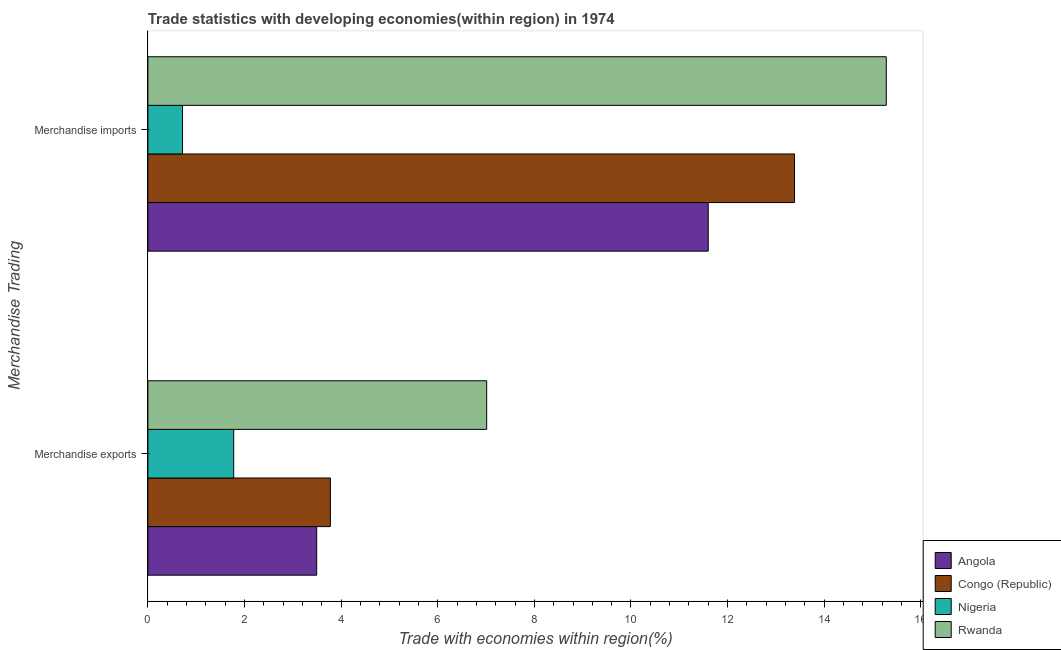How many different coloured bars are there?
Your answer should be compact. 4. How many bars are there on the 2nd tick from the bottom?
Offer a terse response. 4. What is the merchandise exports in Rwanda?
Your answer should be very brief. 7.01. Across all countries, what is the maximum merchandise exports?
Ensure brevity in your answer.  7.01. Across all countries, what is the minimum merchandise exports?
Your response must be concise. 1.78. In which country was the merchandise imports maximum?
Offer a terse response. Rwanda. In which country was the merchandise imports minimum?
Make the answer very short. Nigeria. What is the total merchandise exports in the graph?
Your answer should be compact. 16.06. What is the difference between the merchandise exports in Congo (Republic) and that in Angola?
Provide a succinct answer. 0.28. What is the difference between the merchandise exports in Congo (Republic) and the merchandise imports in Angola?
Keep it short and to the point. -7.82. What is the average merchandise exports per country?
Provide a succinct answer. 4.02. What is the difference between the merchandise exports and merchandise imports in Nigeria?
Your answer should be very brief. 1.06. What is the ratio of the merchandise imports in Angola to that in Congo (Republic)?
Your answer should be compact. 0.87. Is the merchandise exports in Nigeria less than that in Congo (Republic)?
Your answer should be compact. Yes. What does the 3rd bar from the top in Merchandise exports represents?
Provide a succinct answer. Congo (Republic). What does the 4th bar from the bottom in Merchandise imports represents?
Offer a very short reply. Rwanda. How many bars are there?
Ensure brevity in your answer.  8. What is the difference between two consecutive major ticks on the X-axis?
Provide a short and direct response. 2. Does the graph contain any zero values?
Offer a terse response. No. Does the graph contain grids?
Provide a succinct answer. No. Where does the legend appear in the graph?
Ensure brevity in your answer.  Bottom right. How many legend labels are there?
Offer a terse response. 4. How are the legend labels stacked?
Provide a succinct answer. Vertical. What is the title of the graph?
Provide a succinct answer. Trade statistics with developing economies(within region) in 1974. Does "Arab World" appear as one of the legend labels in the graph?
Keep it short and to the point. No. What is the label or title of the X-axis?
Your answer should be compact. Trade with economies within region(%). What is the label or title of the Y-axis?
Offer a terse response. Merchandise Trading. What is the Trade with economies within region(%) in Angola in Merchandise exports?
Offer a very short reply. 3.49. What is the Trade with economies within region(%) of Congo (Republic) in Merchandise exports?
Offer a very short reply. 3.78. What is the Trade with economies within region(%) of Nigeria in Merchandise exports?
Keep it short and to the point. 1.78. What is the Trade with economies within region(%) in Rwanda in Merchandise exports?
Provide a short and direct response. 7.01. What is the Trade with economies within region(%) in Angola in Merchandise imports?
Offer a terse response. 11.6. What is the Trade with economies within region(%) of Congo (Republic) in Merchandise imports?
Provide a short and direct response. 13.39. What is the Trade with economies within region(%) in Nigeria in Merchandise imports?
Make the answer very short. 0.72. What is the Trade with economies within region(%) of Rwanda in Merchandise imports?
Provide a short and direct response. 15.28. Across all Merchandise Trading, what is the maximum Trade with economies within region(%) of Angola?
Ensure brevity in your answer.  11.6. Across all Merchandise Trading, what is the maximum Trade with economies within region(%) in Congo (Republic)?
Make the answer very short. 13.39. Across all Merchandise Trading, what is the maximum Trade with economies within region(%) of Nigeria?
Provide a short and direct response. 1.78. Across all Merchandise Trading, what is the maximum Trade with economies within region(%) in Rwanda?
Your answer should be compact. 15.28. Across all Merchandise Trading, what is the minimum Trade with economies within region(%) in Angola?
Your answer should be very brief. 3.49. Across all Merchandise Trading, what is the minimum Trade with economies within region(%) of Congo (Republic)?
Offer a terse response. 3.78. Across all Merchandise Trading, what is the minimum Trade with economies within region(%) in Nigeria?
Give a very brief answer. 0.72. Across all Merchandise Trading, what is the minimum Trade with economies within region(%) of Rwanda?
Give a very brief answer. 7.01. What is the total Trade with economies within region(%) of Angola in the graph?
Offer a terse response. 15.09. What is the total Trade with economies within region(%) in Congo (Republic) in the graph?
Offer a terse response. 17.16. What is the total Trade with economies within region(%) in Nigeria in the graph?
Provide a succinct answer. 2.49. What is the total Trade with economies within region(%) of Rwanda in the graph?
Offer a very short reply. 22.3. What is the difference between the Trade with economies within region(%) in Angola in Merchandise exports and that in Merchandise imports?
Make the answer very short. -8.1. What is the difference between the Trade with economies within region(%) in Congo (Republic) in Merchandise exports and that in Merchandise imports?
Your answer should be very brief. -9.61. What is the difference between the Trade with economies within region(%) of Nigeria in Merchandise exports and that in Merchandise imports?
Offer a very short reply. 1.06. What is the difference between the Trade with economies within region(%) in Rwanda in Merchandise exports and that in Merchandise imports?
Offer a terse response. -8.27. What is the difference between the Trade with economies within region(%) in Angola in Merchandise exports and the Trade with economies within region(%) in Congo (Republic) in Merchandise imports?
Your response must be concise. -9.89. What is the difference between the Trade with economies within region(%) of Angola in Merchandise exports and the Trade with economies within region(%) of Nigeria in Merchandise imports?
Keep it short and to the point. 2.78. What is the difference between the Trade with economies within region(%) of Angola in Merchandise exports and the Trade with economies within region(%) of Rwanda in Merchandise imports?
Give a very brief answer. -11.79. What is the difference between the Trade with economies within region(%) in Congo (Republic) in Merchandise exports and the Trade with economies within region(%) in Nigeria in Merchandise imports?
Give a very brief answer. 3.06. What is the difference between the Trade with economies within region(%) in Congo (Republic) in Merchandise exports and the Trade with economies within region(%) in Rwanda in Merchandise imports?
Provide a succinct answer. -11.51. What is the difference between the Trade with economies within region(%) of Nigeria in Merchandise exports and the Trade with economies within region(%) of Rwanda in Merchandise imports?
Keep it short and to the point. -13.51. What is the average Trade with economies within region(%) in Angola per Merchandise Trading?
Your response must be concise. 7.55. What is the average Trade with economies within region(%) in Congo (Republic) per Merchandise Trading?
Offer a terse response. 8.58. What is the average Trade with economies within region(%) in Nigeria per Merchandise Trading?
Provide a succinct answer. 1.25. What is the average Trade with economies within region(%) of Rwanda per Merchandise Trading?
Offer a very short reply. 11.15. What is the difference between the Trade with economies within region(%) in Angola and Trade with economies within region(%) in Congo (Republic) in Merchandise exports?
Your answer should be compact. -0.28. What is the difference between the Trade with economies within region(%) of Angola and Trade with economies within region(%) of Nigeria in Merchandise exports?
Offer a terse response. 1.72. What is the difference between the Trade with economies within region(%) in Angola and Trade with economies within region(%) in Rwanda in Merchandise exports?
Ensure brevity in your answer.  -3.52. What is the difference between the Trade with economies within region(%) in Congo (Republic) and Trade with economies within region(%) in Nigeria in Merchandise exports?
Offer a very short reply. 2. What is the difference between the Trade with economies within region(%) in Congo (Republic) and Trade with economies within region(%) in Rwanda in Merchandise exports?
Provide a short and direct response. -3.23. What is the difference between the Trade with economies within region(%) in Nigeria and Trade with economies within region(%) in Rwanda in Merchandise exports?
Your response must be concise. -5.24. What is the difference between the Trade with economies within region(%) of Angola and Trade with economies within region(%) of Congo (Republic) in Merchandise imports?
Make the answer very short. -1.79. What is the difference between the Trade with economies within region(%) in Angola and Trade with economies within region(%) in Nigeria in Merchandise imports?
Your answer should be very brief. 10.88. What is the difference between the Trade with economies within region(%) of Angola and Trade with economies within region(%) of Rwanda in Merchandise imports?
Offer a terse response. -3.69. What is the difference between the Trade with economies within region(%) in Congo (Republic) and Trade with economies within region(%) in Nigeria in Merchandise imports?
Your response must be concise. 12.67. What is the difference between the Trade with economies within region(%) in Congo (Republic) and Trade with economies within region(%) in Rwanda in Merchandise imports?
Offer a terse response. -1.9. What is the difference between the Trade with economies within region(%) in Nigeria and Trade with economies within region(%) in Rwanda in Merchandise imports?
Provide a short and direct response. -14.57. What is the ratio of the Trade with economies within region(%) in Angola in Merchandise exports to that in Merchandise imports?
Offer a terse response. 0.3. What is the ratio of the Trade with economies within region(%) in Congo (Republic) in Merchandise exports to that in Merchandise imports?
Your answer should be compact. 0.28. What is the ratio of the Trade with economies within region(%) of Nigeria in Merchandise exports to that in Merchandise imports?
Ensure brevity in your answer.  2.48. What is the ratio of the Trade with economies within region(%) of Rwanda in Merchandise exports to that in Merchandise imports?
Offer a terse response. 0.46. What is the difference between the highest and the second highest Trade with economies within region(%) of Angola?
Offer a terse response. 8.1. What is the difference between the highest and the second highest Trade with economies within region(%) in Congo (Republic)?
Provide a succinct answer. 9.61. What is the difference between the highest and the second highest Trade with economies within region(%) in Nigeria?
Offer a terse response. 1.06. What is the difference between the highest and the second highest Trade with economies within region(%) of Rwanda?
Your answer should be very brief. 8.27. What is the difference between the highest and the lowest Trade with economies within region(%) in Angola?
Your answer should be compact. 8.1. What is the difference between the highest and the lowest Trade with economies within region(%) in Congo (Republic)?
Give a very brief answer. 9.61. What is the difference between the highest and the lowest Trade with economies within region(%) in Nigeria?
Ensure brevity in your answer.  1.06. What is the difference between the highest and the lowest Trade with economies within region(%) in Rwanda?
Give a very brief answer. 8.27. 